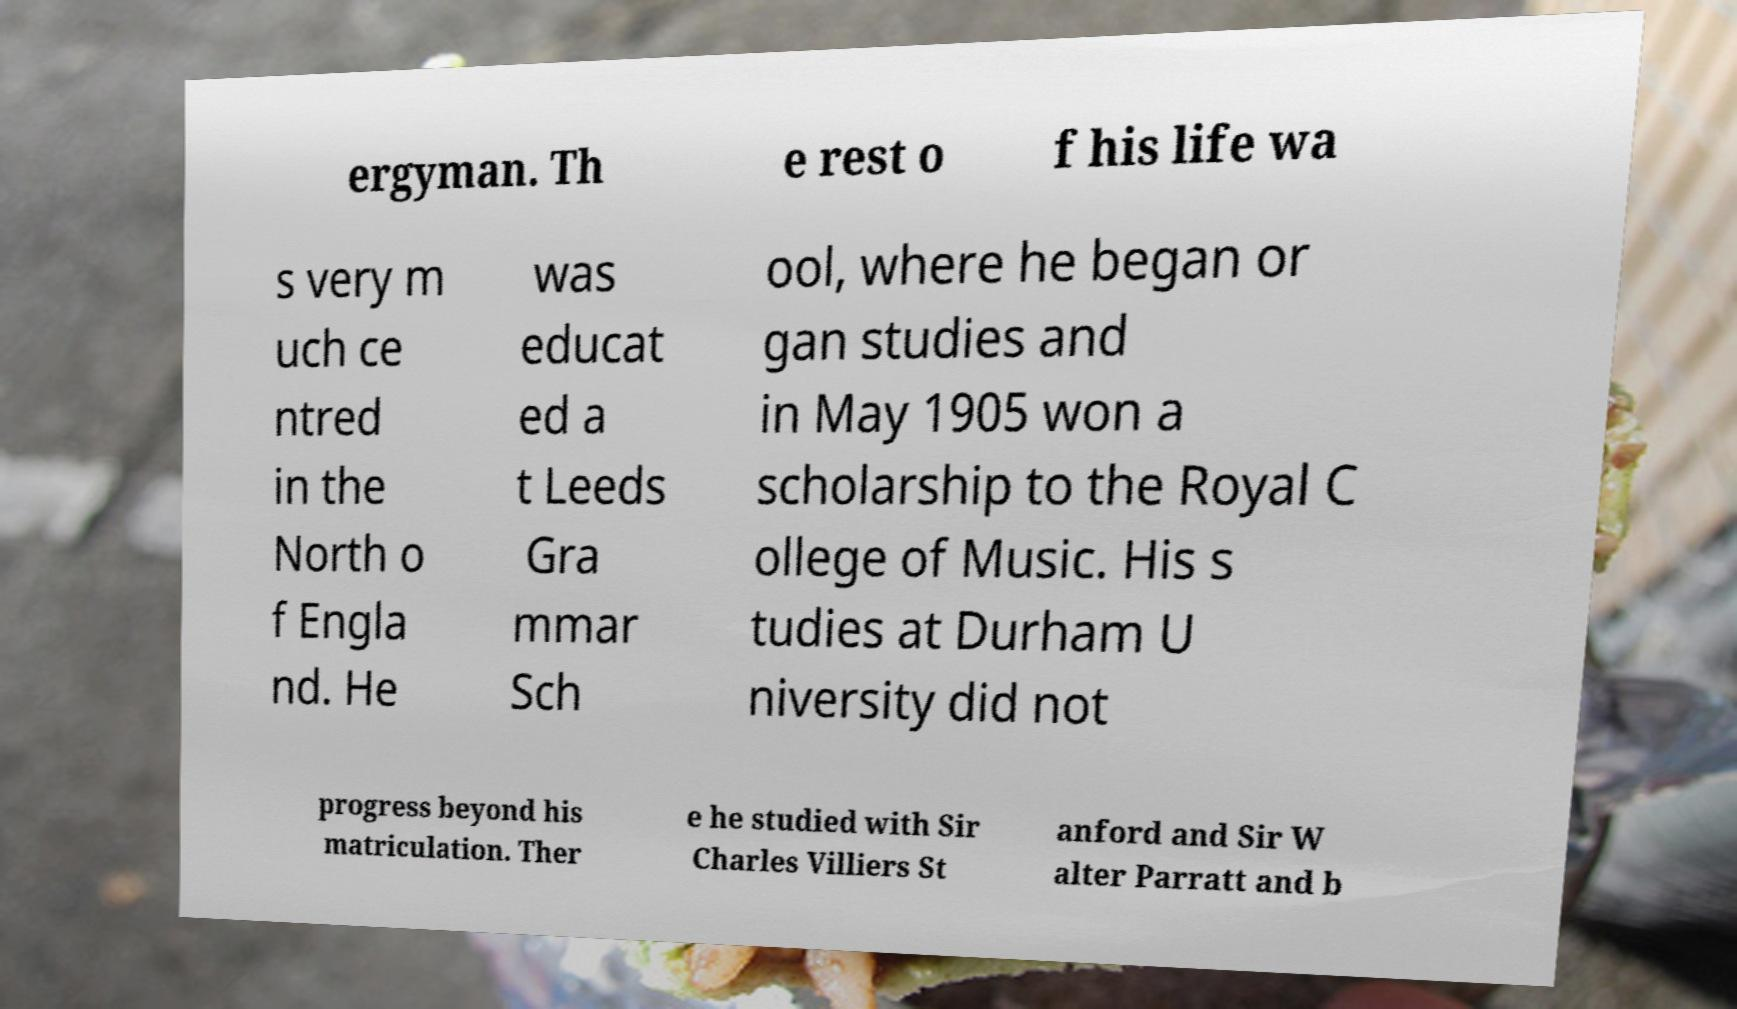Please identify and transcribe the text found in this image. ergyman. Th e rest o f his life wa s very m uch ce ntred in the North o f Engla nd. He was educat ed a t Leeds Gra mmar Sch ool, where he began or gan studies and in May 1905 won a scholarship to the Royal C ollege of Music. His s tudies at Durham U niversity did not progress beyond his matriculation. Ther e he studied with Sir Charles Villiers St anford and Sir W alter Parratt and b 